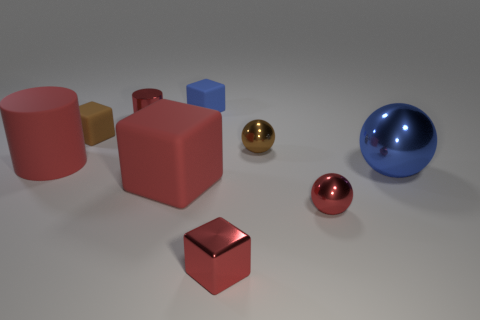Add 9 rubber cylinders. How many rubber cylinders exist? 10 Subtract all red spheres. How many spheres are left? 2 Subtract all tiny red metallic blocks. How many blocks are left? 3 Subtract 1 red cylinders. How many objects are left? 8 Subtract all blocks. How many objects are left? 5 Subtract 1 blocks. How many blocks are left? 3 Subtract all yellow cylinders. Subtract all gray spheres. How many cylinders are left? 2 Subtract all purple spheres. How many red cubes are left? 2 Subtract all small red metallic blocks. Subtract all tiny brown balls. How many objects are left? 7 Add 9 tiny brown matte cubes. How many tiny brown matte cubes are left? 10 